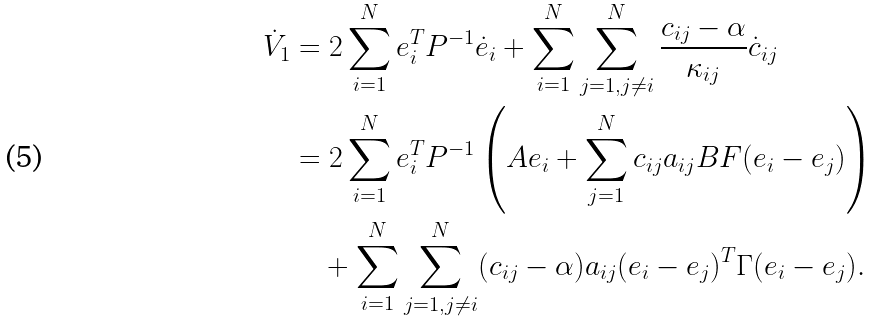Convert formula to latex. <formula><loc_0><loc_0><loc_500><loc_500>\dot { V } _ { 1 } & = 2 \sum _ { i = 1 } ^ { N } e _ { i } ^ { T } P ^ { - 1 } \dot { e } _ { i } + \sum _ { i = 1 } ^ { N } \sum _ { j = 1 , j \neq i } ^ { N } \frac { c _ { i j } - \alpha } { \kappa _ { i j } } \dot { c } _ { i j } \\ & = 2 \sum _ { i = 1 } ^ { N } e _ { i } ^ { T } P ^ { - 1 } \left ( A e _ { i } + \sum _ { j = 1 } ^ { N } c _ { i j } a _ { i j } B F ( e _ { i } - e _ { j } ) \right ) \\ & \quad + \sum _ { i = 1 } ^ { N } \sum _ { j = 1 , j \neq i } ^ { N } ( c _ { i j } - \alpha ) a _ { i j } ( e _ { i } - e _ { j } ) ^ { T } \Gamma ( e _ { i } - e _ { j } ) .</formula> 